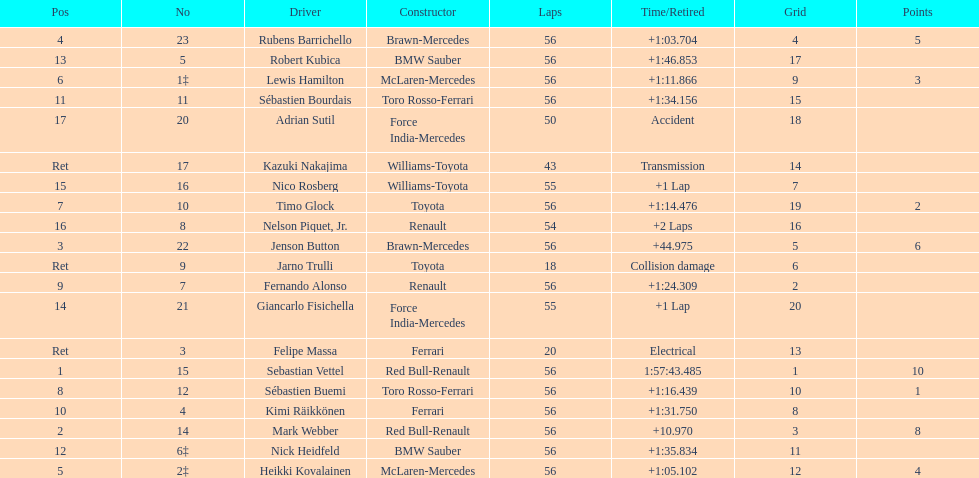What is the name of a driver that ferrari was not a constructor for? Sebastian Vettel. 